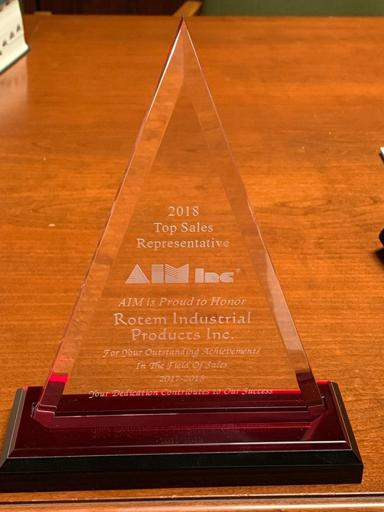What was the achievement of Rotem Industrial Products Inc. in 2018? Rotem Industrial Products Inc. was honored as the 2018 Top Sales Representative by AIM. What is the design of the glass award in the image? The award has a triangle design on it. 